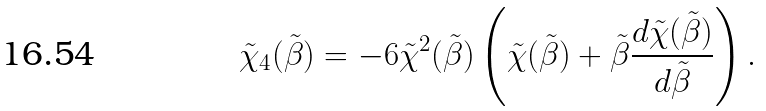<formula> <loc_0><loc_0><loc_500><loc_500>\tilde { \chi } _ { 4 } ( \tilde { \beta } ) = - 6 \tilde { \chi } ^ { 2 } ( \tilde { \beta } ) \left ( \tilde { \chi } ( \tilde { \beta } ) + \tilde { \beta } \frac { d \tilde { \chi } ( \tilde { \beta } ) } { d \tilde { \beta } } \right ) .</formula> 